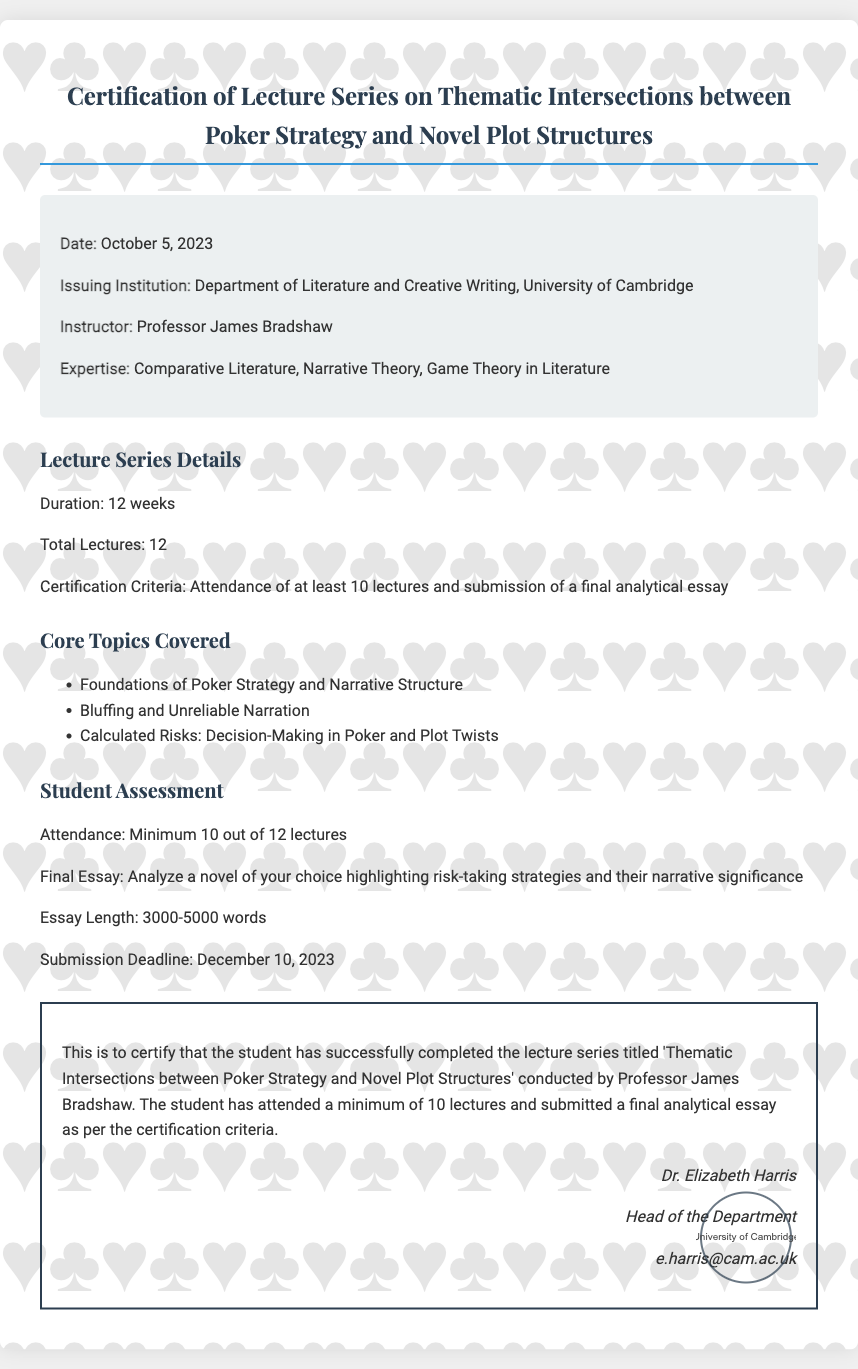What is the date of issuance? The date of issuance is stated in the details section of the document.
Answer: October 5, 2023 Who is the instructor of the lecture series? The instructor's name is mentioned in the details section.
Answer: Professor James Bradshaw What is the minimum attendance required for certification? This information is found under the Student Assessment section.
Answer: 10 lectures What is the length of the final essay? The essay length is specified in the Student Assessment section.
Answer: 3000-5000 words What is the submission deadline for the final essay? The submission deadline is clearly stated in the Student Assessment section.
Answer: December 10, 2023 How many total lectures are there in the series? The total number of lectures is listed in the lecture series details.
Answer: 12 What are the core topics covered in the lecture series? The core topics are specified in a bulleted list under Core Topics Covered.
Answer: Bluffing and Unreliable Narration What is the main purpose of the document? The purpose of the document can be inferred from the declaration section.
Answer: Certification of Completion 